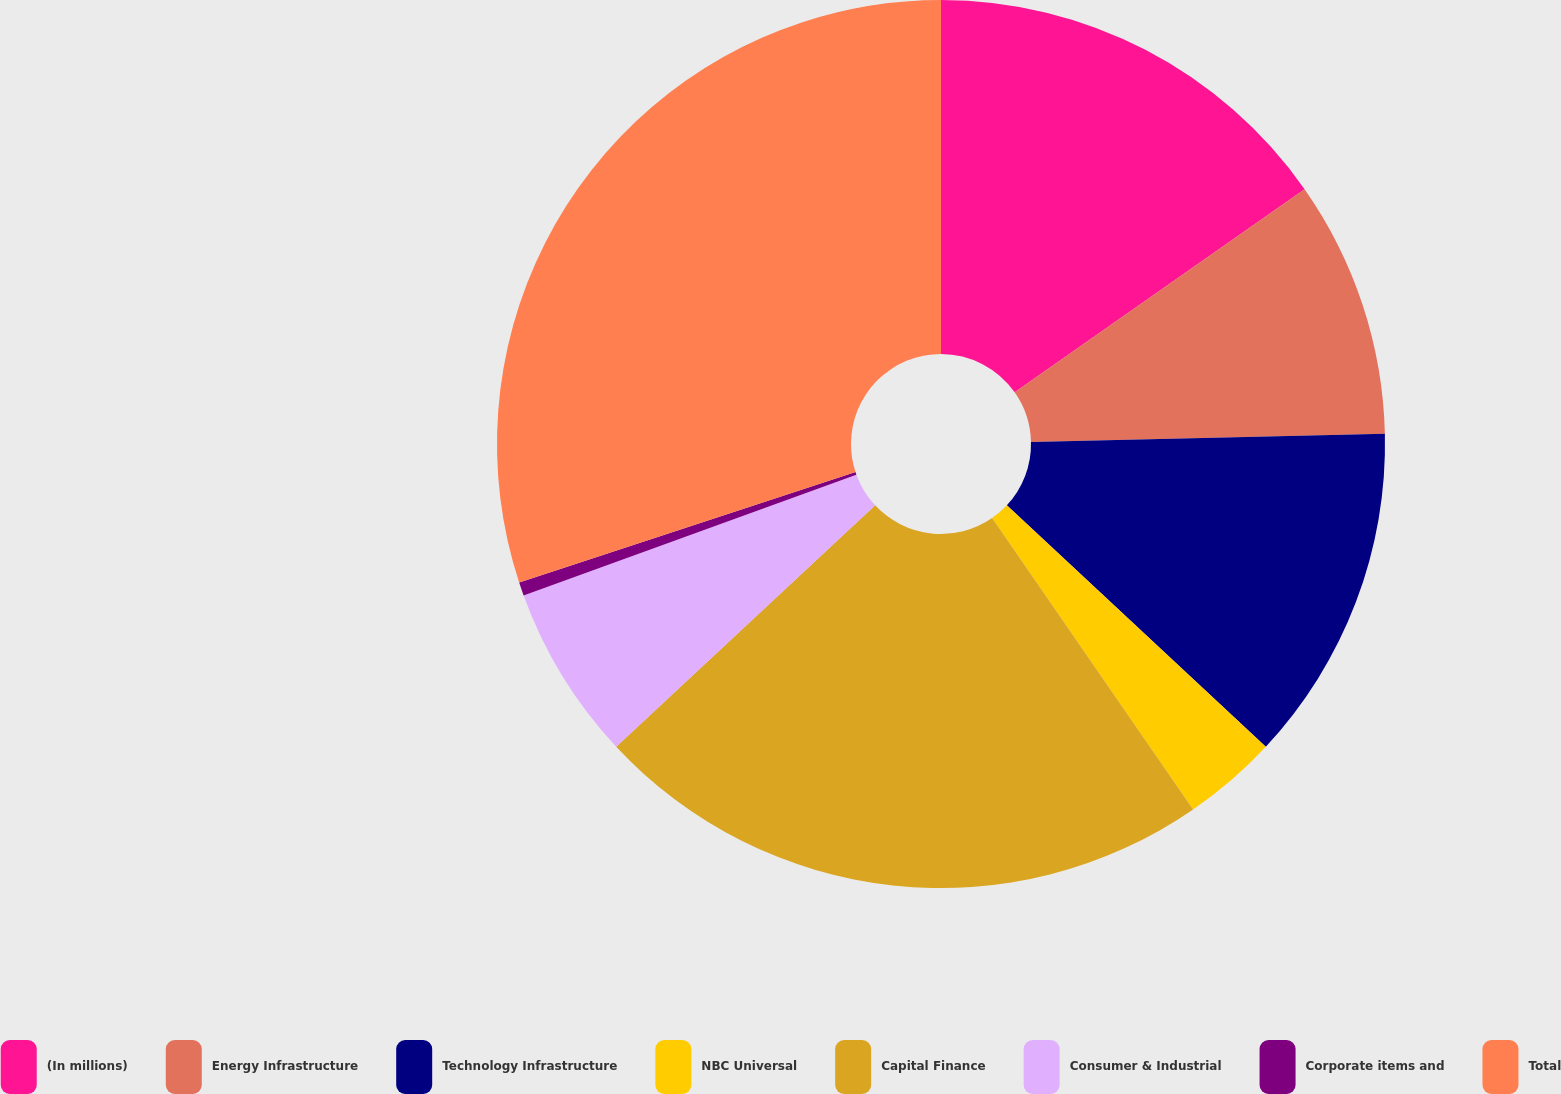<chart> <loc_0><loc_0><loc_500><loc_500><pie_chart><fcel>(In millions)<fcel>Energy Infrastructure<fcel>Technology Infrastructure<fcel>NBC Universal<fcel>Capital Finance<fcel>Consumer & Industrial<fcel>Corporate items and<fcel>Total<nl><fcel>15.27%<fcel>9.36%<fcel>12.31%<fcel>3.45%<fcel>22.67%<fcel>6.4%<fcel>0.49%<fcel>30.05%<nl></chart> 